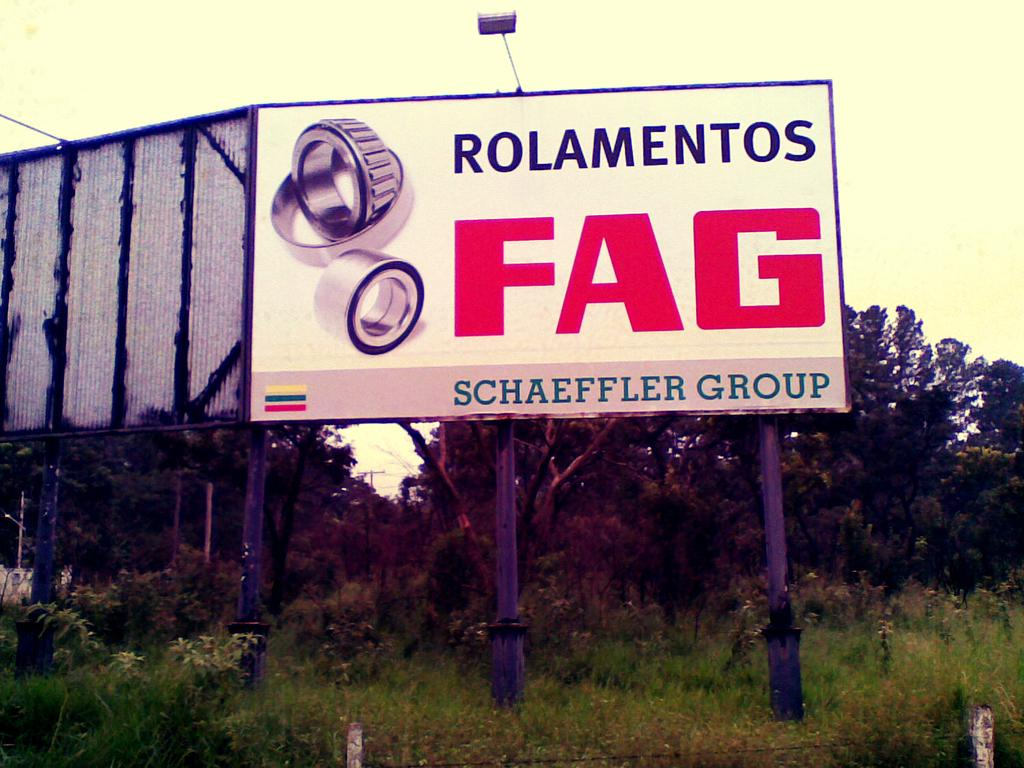<image>
Summarize the visual content of the image. A poster advertises the FAG brand in large red letters. 